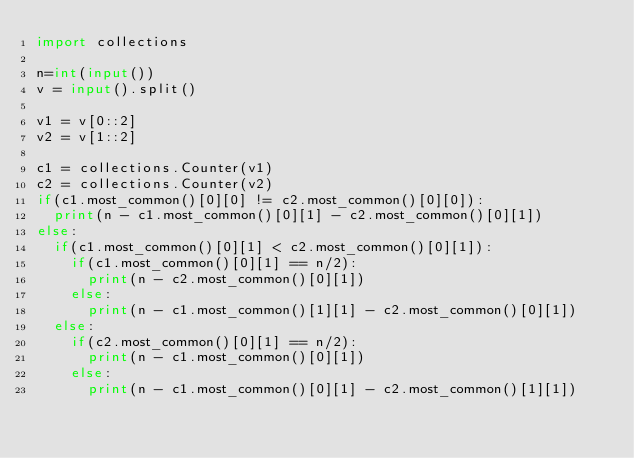<code> <loc_0><loc_0><loc_500><loc_500><_Python_>import collections

n=int(input())
v = input().split()

v1 = v[0::2]
v2 = v[1::2]

c1 = collections.Counter(v1)
c2 = collections.Counter(v2)
if(c1.most_common()[0][0] != c2.most_common()[0][0]):
	print(n - c1.most_common()[0][1] - c2.most_common()[0][1])
else:
	if(c1.most_common()[0][1] < c2.most_common()[0][1]):
		if(c1.most_common()[0][1] == n/2):
			print(n - c2.most_common()[0][1])
		else:
			print(n - c1.most_common()[1][1] - c2.most_common()[0][1])
	else:
		if(c2.most_common()[0][1] == n/2):
			print(n - c1.most_common()[0][1])
		else:
			print(n - c1.most_common()[0][1] - c2.most_common()[1][1])
</code> 